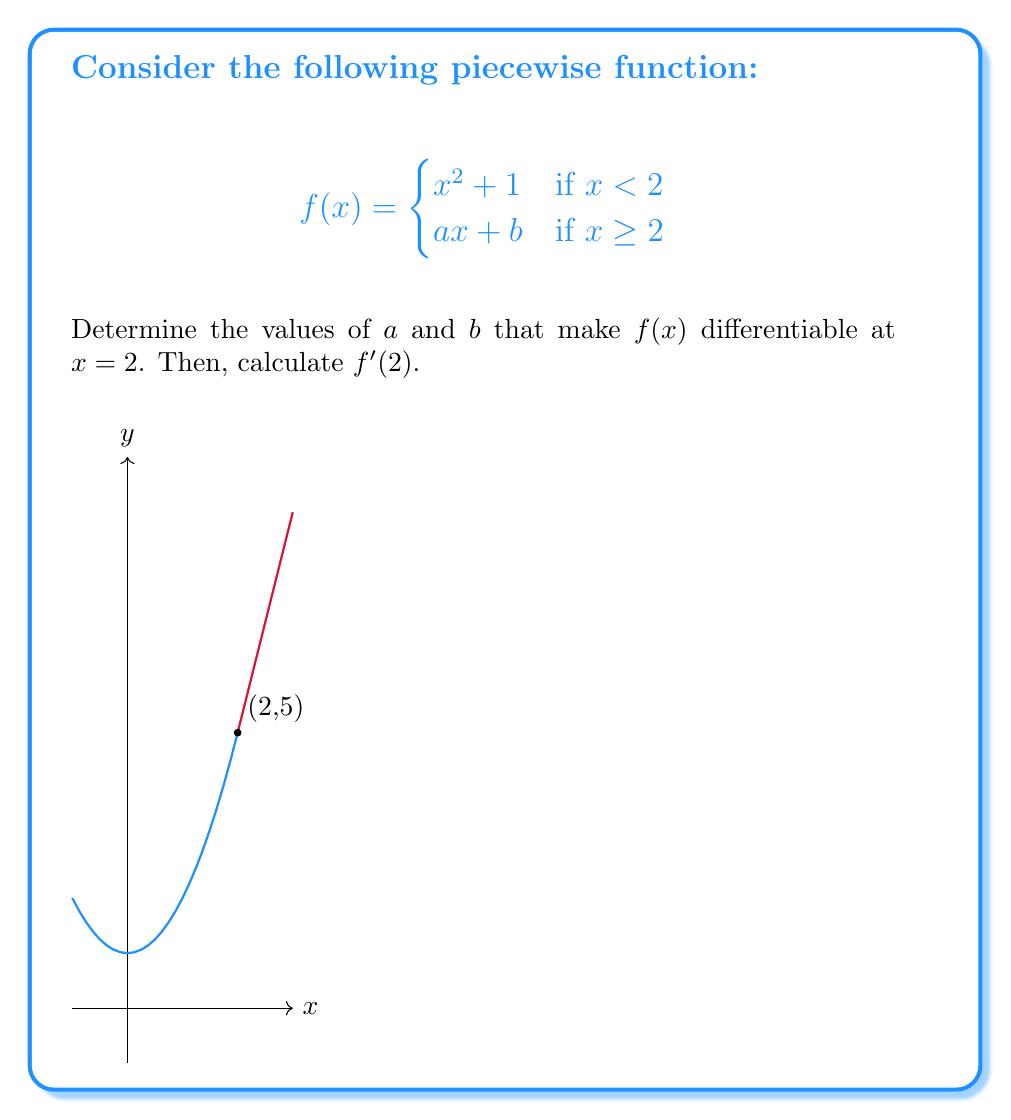Solve this math problem. To determine the differentiability of $f(x)$ at $x = 2$, we need to ensure two conditions:

1. Continuity at $x = 2$
2. Existence of the derivative at $x = 2$

Step 1: Ensure continuity at $x = 2$
For continuity, the left-hand limit must equal the right-hand limit:

$$\lim_{x \to 2^-} f(x) = \lim_{x \to 2^+} f(x)$$

Left-hand limit: $\lim_{x \to 2^-} (x^2 + 1) = 2^2 + 1 = 5$
Right-hand limit: $\lim_{x \to 2^+} (ax + b) = 2a + b$

For continuity: $5 = 2a + b$ (Equation 1)

Step 2: Ensure the existence of the derivative at $x = 2$
For the function to be differentiable, the left-hand and right-hand derivatives must exist and be equal:

Left-hand derivative: $\lim_{h \to 0^-} \frac{f(2+h) - f(2)}{h} = \lim_{h \to 0^-} \frac{(2+h)^2 + 1 - 5}{h} = 4$

Right-hand derivative: $\lim_{h \to 0^+} \frac{f(2+h) - f(2)}{h} = \lim_{h \to 0^+} \frac{a(2+h) + b - (2a+b)}{h} = a$

For differentiability: $4 = a$ (Equation 2)

Step 3: Solve for $a$ and $b$
From Equation 2, we know $a = 4$
Substituting this into Equation 1: $5 = 2(4) + b$
Solving for $b$: $b = 5 - 8 = -3$

Step 4: Calculate $f'(2)$
Since we've ensured differentiability, $f'(2)$ exists and equals the common value of the left-hand and right-hand derivatives, which is 4.
Answer: $a = 4$, $b = -3$, $f'(2) = 4$ 